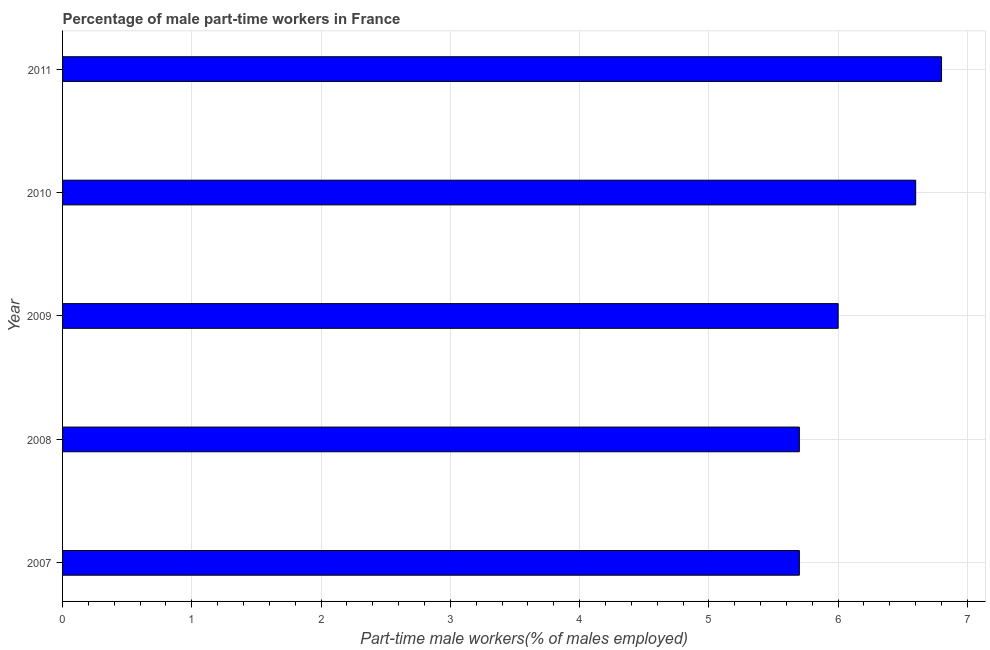Does the graph contain any zero values?
Provide a short and direct response. No. What is the title of the graph?
Keep it short and to the point. Percentage of male part-time workers in France. What is the label or title of the X-axis?
Provide a succinct answer. Part-time male workers(% of males employed). What is the label or title of the Y-axis?
Your answer should be compact. Year. What is the percentage of part-time male workers in 2011?
Make the answer very short. 6.8. Across all years, what is the maximum percentage of part-time male workers?
Your answer should be compact. 6.8. Across all years, what is the minimum percentage of part-time male workers?
Your response must be concise. 5.7. In which year was the percentage of part-time male workers maximum?
Provide a succinct answer. 2011. In which year was the percentage of part-time male workers minimum?
Ensure brevity in your answer.  2007. What is the sum of the percentage of part-time male workers?
Provide a succinct answer. 30.8. What is the difference between the percentage of part-time male workers in 2007 and 2011?
Give a very brief answer. -1.1. What is the average percentage of part-time male workers per year?
Offer a terse response. 6.16. What is the median percentage of part-time male workers?
Offer a terse response. 6. Is the percentage of part-time male workers in 2007 less than that in 2011?
Keep it short and to the point. Yes. Is the sum of the percentage of part-time male workers in 2008 and 2009 greater than the maximum percentage of part-time male workers across all years?
Make the answer very short. Yes. In how many years, is the percentage of part-time male workers greater than the average percentage of part-time male workers taken over all years?
Ensure brevity in your answer.  2. How many bars are there?
Offer a very short reply. 5. What is the Part-time male workers(% of males employed) of 2007?
Your answer should be compact. 5.7. What is the Part-time male workers(% of males employed) in 2008?
Provide a short and direct response. 5.7. What is the Part-time male workers(% of males employed) of 2009?
Your answer should be compact. 6. What is the Part-time male workers(% of males employed) of 2010?
Keep it short and to the point. 6.6. What is the Part-time male workers(% of males employed) of 2011?
Ensure brevity in your answer.  6.8. What is the difference between the Part-time male workers(% of males employed) in 2007 and 2008?
Ensure brevity in your answer.  0. What is the difference between the Part-time male workers(% of males employed) in 2007 and 2010?
Offer a terse response. -0.9. What is the difference between the Part-time male workers(% of males employed) in 2008 and 2009?
Keep it short and to the point. -0.3. What is the difference between the Part-time male workers(% of males employed) in 2008 and 2010?
Provide a short and direct response. -0.9. What is the difference between the Part-time male workers(% of males employed) in 2008 and 2011?
Offer a terse response. -1.1. What is the difference between the Part-time male workers(% of males employed) in 2009 and 2010?
Your response must be concise. -0.6. What is the difference between the Part-time male workers(% of males employed) in 2009 and 2011?
Give a very brief answer. -0.8. What is the ratio of the Part-time male workers(% of males employed) in 2007 to that in 2010?
Offer a terse response. 0.86. What is the ratio of the Part-time male workers(% of males employed) in 2007 to that in 2011?
Provide a succinct answer. 0.84. What is the ratio of the Part-time male workers(% of males employed) in 2008 to that in 2010?
Your answer should be compact. 0.86. What is the ratio of the Part-time male workers(% of males employed) in 2008 to that in 2011?
Offer a terse response. 0.84. What is the ratio of the Part-time male workers(% of males employed) in 2009 to that in 2010?
Your answer should be compact. 0.91. What is the ratio of the Part-time male workers(% of males employed) in 2009 to that in 2011?
Keep it short and to the point. 0.88. What is the ratio of the Part-time male workers(% of males employed) in 2010 to that in 2011?
Offer a very short reply. 0.97. 